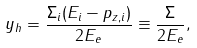Convert formula to latex. <formula><loc_0><loc_0><loc_500><loc_500>y _ { h } = \frac { \Sigma _ { i } ( E _ { i } - p _ { z , i } ) } { 2 E _ { e } } \equiv \frac { \Sigma } { 2 E _ { e } } ,</formula> 